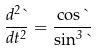<formula> <loc_0><loc_0><loc_500><loc_500>\frac { d ^ { 2 } \theta } { d t ^ { 2 } } = \frac { \cos \theta } { \sin ^ { 3 } \theta }</formula> 